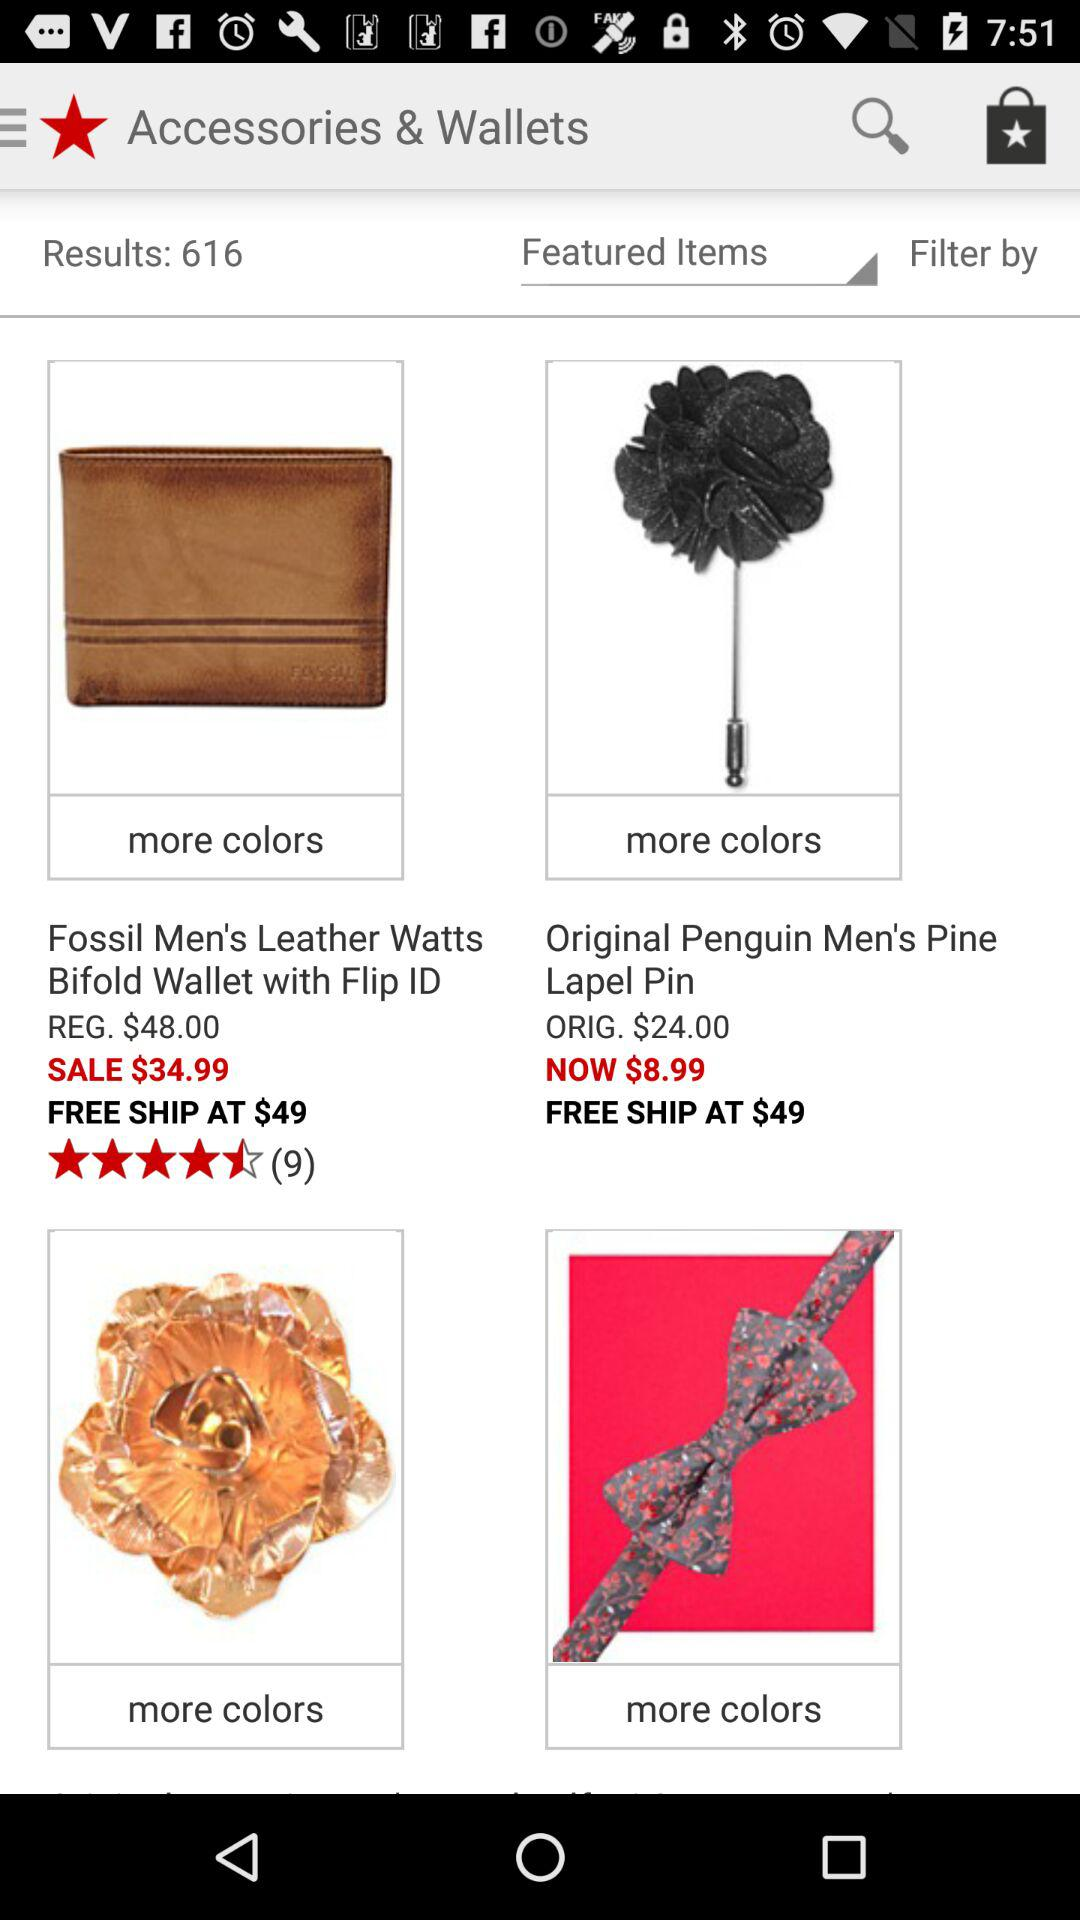What is the price of "Pine Lapel Pin" after discount? The price is $8.99. 